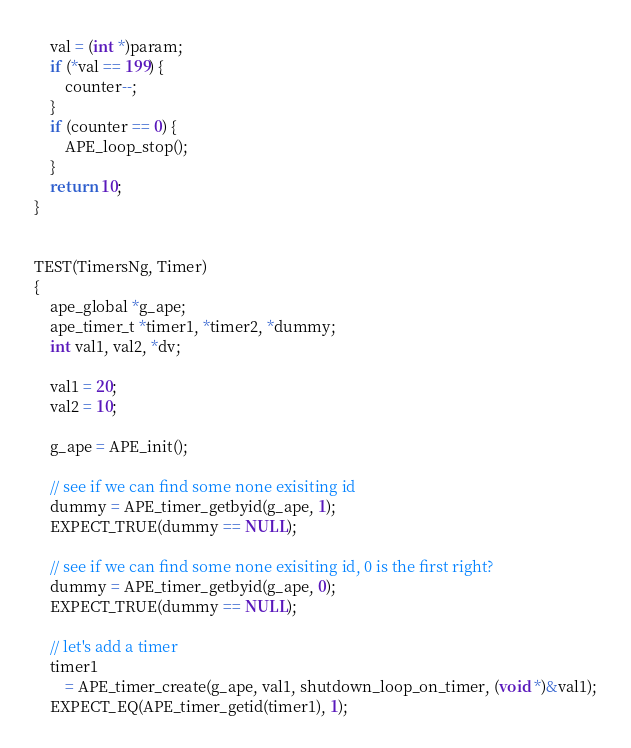<code> <loc_0><loc_0><loc_500><loc_500><_C++_>    val = (int *)param;
    if (*val == 199) {
        counter--;
    }
    if (counter == 0) {
        APE_loop_stop();
    }
    return 10;
}


TEST(TimersNg, Timer)
{
    ape_global *g_ape;
    ape_timer_t *timer1, *timer2, *dummy;
    int val1, val2, *dv;

    val1 = 20;
    val2 = 10;

    g_ape = APE_init();

    // see if we can find some none exisiting id
    dummy = APE_timer_getbyid(g_ape, 1);
    EXPECT_TRUE(dummy == NULL);

    // see if we can find some none exisiting id, 0 is the first right?
    dummy = APE_timer_getbyid(g_ape, 0);
    EXPECT_TRUE(dummy == NULL);

    // let's add a timer
    timer1
        = APE_timer_create(g_ape, val1, shutdown_loop_on_timer, (void *)&val1);
    EXPECT_EQ(APE_timer_getid(timer1), 1);</code> 